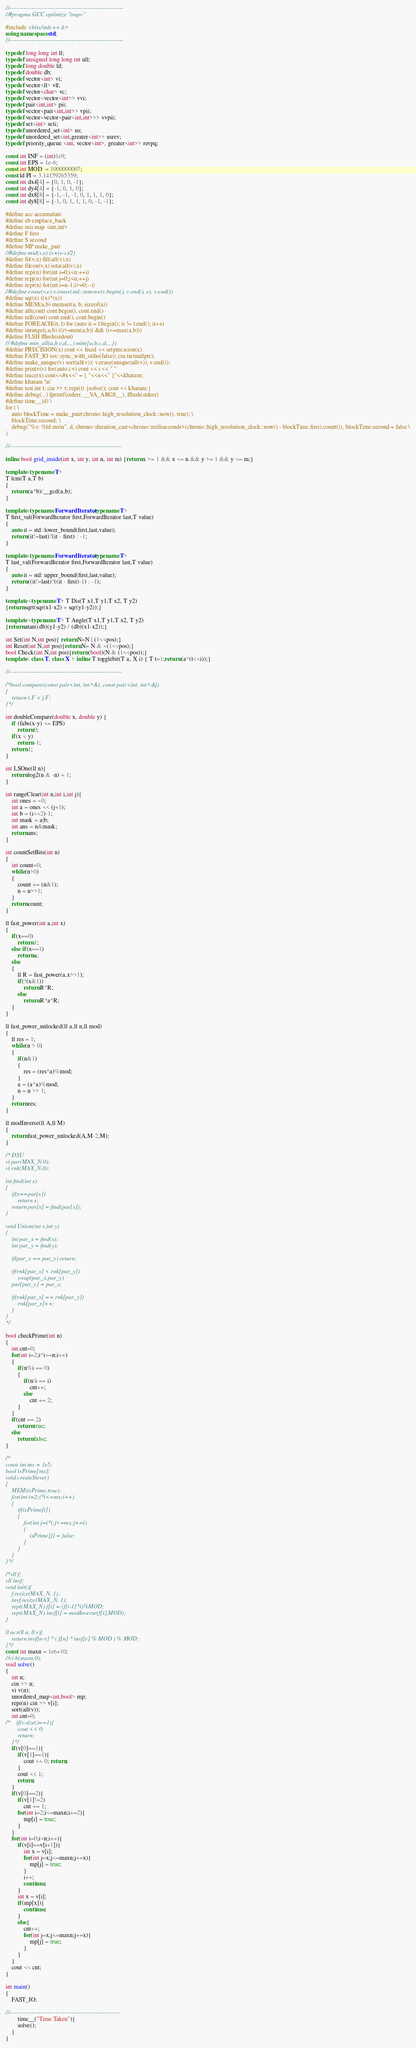Convert code to text. <code><loc_0><loc_0><loc_500><loc_500><_C++_>
//---------------------------------------------------------
//#pragma GCC optimize "trapv"

#include <bits/stdc++.h>
using namespace std;
//---------------------------------------------------------

typedef long long int ll;
typedef unsigned long long int ull;
typedef long double ld;
typedef double db;
typedef vector<int> vi;
typedef vector<ll> vll;
typedef vector<char> vc;
typedef vector<vector<int>> vvi;
typedef pair<int,int> pii;
typedef vector<pair<int,int>> vpii;
typedef vector<vector<pair<int,int>>> vvpii;
typedef set<int> seti;
typedef unordered_set<int> us;
typedef unordered_set<int,greater<int>> usrev;
typedef priority_queue <int, vector<int>, greater<int>> revpq;

const int INF = (int)1e9;
const int EPS = 1e-6;
const int MOD  = 1000000007;
const ld PI = 3.14159265359;
const int dx4[4] = {0, 1, 0, -1};
const int dy4[4] = {-1, 0, 1, 0};
const int dx8[8] = {-1, -1, -1, 0, 1, 1, 1, 0};
const int dy8[8] = {-1, 0, 1, 1, 1, 0, -1, -1};

#define acc accumulate
#define eb emplace_back
#define mii map <int,int>
#define F first
#define S second
#define MP make_pair
//#define mid(s,e) (s+(e-s)/2)
#define fil(v,x) fill(all(v),x)
#define filcon(v,x) iota(all(v),x)
#define repi(n) for(int i=0;i<n;++i)
#define repj(n) for(int j=0;j<n;++j)
#define repr(n) for(int i=n-1;i>=0;--i)
//#define erase(v,e) v.erase(std::remove(v.begin(), v.end(), e), v.end())
#define sqr(x) ((x)*(x))
#define MEM(a,b) memset(a, b, sizeof(a))
#define all(cont) cont.begin(), cont.end()
#define rall(cont) cont.end(), cont.begin()
#define FOREACH(it, l) for (auto it = l.begin(); it != l.end(); it++)
#define inrange(i,a,b) ((i>=min(a,b)) && (i<=max(a,b)))
#define FLSH fflush(stdout)
// #define min_all(a,b,c,d,...) min({a,b,c,d,...})
#define PRECISION(x) cout << fixed << setprecision(x)
#define FAST_IO ios::sync_with_stdio(false); cin.tie(nullptr);
#define make_unique(v) sort(all(v)); v.erase(unique(all(v)), v.end());
#define printv(v) for(auto i:v) cout << i << " "
#define trace(x) cout<<#x<<" = { "<<x<<" }"<<khatam;
#define khatam '\n'
#define test int t; cin >> t; repi(t) {solve(); cout << khatam;}
#define debug(...) fprintf(stderr, __VA_ARGS__), fflush(stderr)
#define time__(d) \
for ( \
    auto blockTime = make_pair(chrono::high_resolution_clock::now(), true); \
    blockTime.second; \
    debug("%s: %ld ms\n", d, chrono::duration_cast<chrono::milliseconds>(chrono::high_resolution_clock::now() - blockTime.first).count()), blockTime.second = false \
)

//--------------------------------------------------------

inline bool grid_inside(int x, int y, int n, int m) {return x >= 1 && x <= n && y >= 1 && y <= m;}

template<typename T>
T lcm(T a,T b)
{
    return (a*b)/__gcd(a,b);
}

template<typename ForwardIterator,typename T>
T first_val(ForwardIterator first,ForwardIterator last,T value)
{
    auto it = std::lower_bound(first,last,value);
    return (it!=last)?(it - first) : -1;
}

template<typename ForwardIterator,typename T>
T last_val(ForwardIterator first,ForwardIterator last,T value)
{
    auto it = std::upper_bound(first,last,value);
    return ((it!=last)?((it - first)-1) : -1);
}

template <typename T> T Dis(T x1,T y1,T x2, T y2)
{return sqrt(sqr(x1-x2) + sqr(y1-y2));}

template <typename T> T Angle(T x1,T y1,T x2, T y2)
{return atan((db)(y1-y2) / (db)(x1-x2));}

int Set(int N,int pos){ return N=N | (1<<pos);}
int Reset(int N,int pos){return N= N & ~(1<<pos);}
bool Check(int N,int pos){return (bool)(N & (1<<pos));}
template< class T, class X > inline T togglebit(T a, X i) { T t=1;return (a^(t<<i));}

//--------------------------------------------------------

/*bool compare(const pair<int, int>&i, const pair<int, int>&j)
{
    return i.F < j.F;
}*/

int doubleCompare(double x, double y) {
    if (fabs(x-y) <= EPS)
        return 0;
    if(x < y)
        return -1;
    return 1;
}

int LSOne(ll n){
    return log2(n & -n) + 1;
}

int rangeClear(int n,int i,int j){
    int ones = ~0;
    int a = ones << (j+1);
    int b = (i<<2)-1;
    int mask = a|b;
    int ans = n&mask;
    return ans;
}

int countSetBits(int n)
{
    int count=0;
    while(n>0)
    {
        count += (n&1);
        n = n>>1;
    }
    return count;
}

ll fast_power(int a,int x)
{
    if(x==0)
        return 1;
    else if(x==1)
        return a;
    else
    {
        ll R = fast_power(a,x>>1);
        if(!(x&1))
            return R*R;
        else
            return R*a*R;
    }
}

ll fast_power_unlocked(ll a,ll n,ll mod)
{
    ll res = 1;
    while(n > 0)
    {
        if(n&1)
        {
            res = (res*a)%mod;
        }
        a = (a*a)%mod;
        n = n >> 1;
    }
    return res;
}

ll modInverse(ll A,ll M)
{
    return fast_power_unlocked(A,M-2,M);
}

/* DSU
vi par(MAX_N,0);
vi rnk(MAX_N,0);

int find(int x)
{
    if(x==par[x])
        return x;
    return par[x] = find(par[x]);
}

void Union(int x,int y)
{
    int par_x = find(x);
    int par_y = find(y);

    if(par_x == par_y) return;

    if(rnk[par_x] < rnk[par_y])
        swap(par_x,par_y)
    par[par_y] = par_x;

    if(rnk[par_x] == rnk[par_y])
        rnk[par_x]++;
    }
}
*/

bool checkPrime(int n)
{
    int cnt=0;
    for(int i=2;i*i<=n;i++)
    {
        if(n%i == 0)
        {
            if(n/i == i)
                cnt++;
            else
                cnt += 2;
        }
    }
    if(cnt == 2)
        return true;
    else
        return false;
}

/*
const int mx = 1e5;
bool isPrime[mx];
void createSieve()
{
    MEM(isPrime,true);
    for(int i=2;i*i<=mx;i++)
    {
        if(isPrime[i])
        {
            for(int j=i*i;j<=mx;j+=i)
            {
                isPrime[j] = false;
            }
        }
    }
}*/

/*vll f;
vll invf;
void init(){
    f.resize(MAX_N, 1);
    invf.resize(MAX_N, 1);
    repi(MAX_N) f[i] = (f[i-1]*i)%MOD;
    repi(MAX_N) invf[i] = modInverse(f[i],MOD);
}

ll ncr(ll n, ll r){
    return invf[n-r] * ( f[n] * invf[r] % MOD ) % MOD;
}*/
const int maxn = 1e6+10;
//vi h(maxn,0);
void solve()
{
    int n;
    cin >> n;
    vi v(n);
    unordered_map<int,bool> mp;
    repi(n) cin >> v[i];
    sort(all(v));
    int cnt=0;
/*    if(v.size()==1){
        cout << 0;
        return;
    }*/
    if(v[0]==1){
        if(v[1]==1){
            cout << 0; return;
        }
        cout << 1;
        return;
    }
    if(v[0]==2){
        if(v[1]!=2)
            cnt += 1;
        for(int i=2;i<=maxn;i+=2){
            mp[i] = true;
        }
    }
    for(int i=0;i<n;i++){
        if(v[i]==v[i+1]){
            int x = v[i];
            for(int j=x;j<=maxn;j+=x){
                mp[j] = true;
            }
            i++;
            continue;
        }
        int x = v[i];
        if(mp[x]){
            continue;
        }
        else{
            cnt++;
            for(int j=x;j<=maxn;j+=x){
                mp[j] = true;
            }
        }
    }
    cout << cnt;
}

int main()
{
    FAST_IO;

//-------------------------------------------------------
        time__("Time Taken"){
        solve();
    }
}</code> 